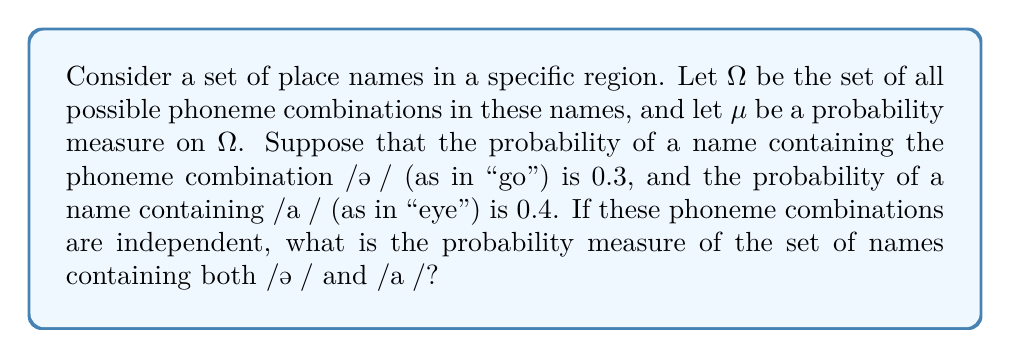Help me with this question. To solve this problem, we'll use measure theory concepts and the properties of probability measures:

1) Let $A$ be the set of names containing /əʊ/ and $B$ be the set of names containing /aɪ/.

2) Given:
   $\mu(A) = 0.3$
   $\mu(B) = 0.4$

3) We need to find $\mu(A \cap B)$, which is the probability of names containing both phoneme combinations.

4) Since the phoneme combinations are independent, we can use the multiplication rule of probability:

   $$\mu(A \cap B) = \mu(A) \cdot \mu(B)$$

5) Substituting the given probabilities:

   $$\mu(A \cap B) = 0.3 \cdot 0.4$$

6) Calculating:

   $$\mu(A \cap B) = 0.12$$

Therefore, the probability measure of the set of names containing both /əʊ/ and /aɪ/ is 0.12 or 12%.

This result aligns with measure theory principles, where the measure of the intersection of independent events is the product of their individual measures.
Answer: $\mu(A \cap B) = 0.12$ 